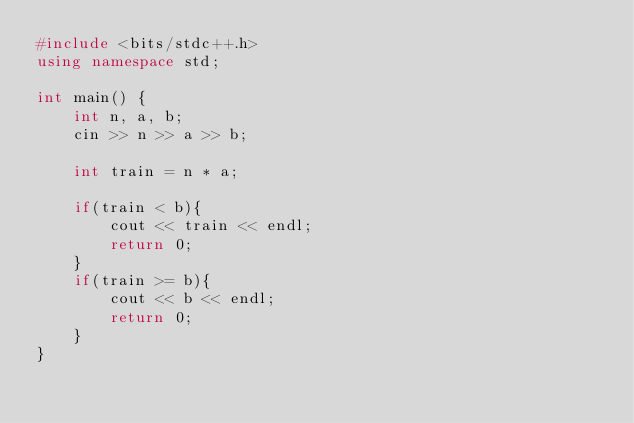<code> <loc_0><loc_0><loc_500><loc_500><_C++_>#include <bits/stdc++.h>
using namespace std;

int main() {
    int n, a, b;
    cin >> n >> a >> b;

    int train = n * a;

    if(train < b){
        cout << train << endl;
        return 0;
    }
    if(train >= b){
        cout << b << endl;
        return 0;
    }
}</code> 